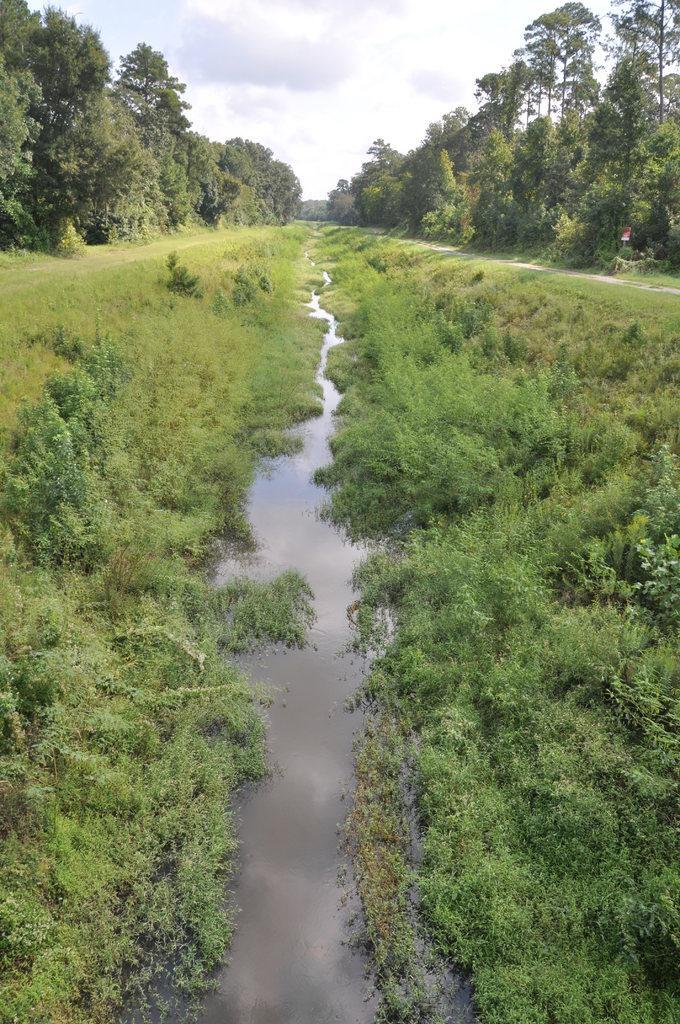In one or two sentences, can you explain what this image depicts? There is water, grass and trees on the either sides. 